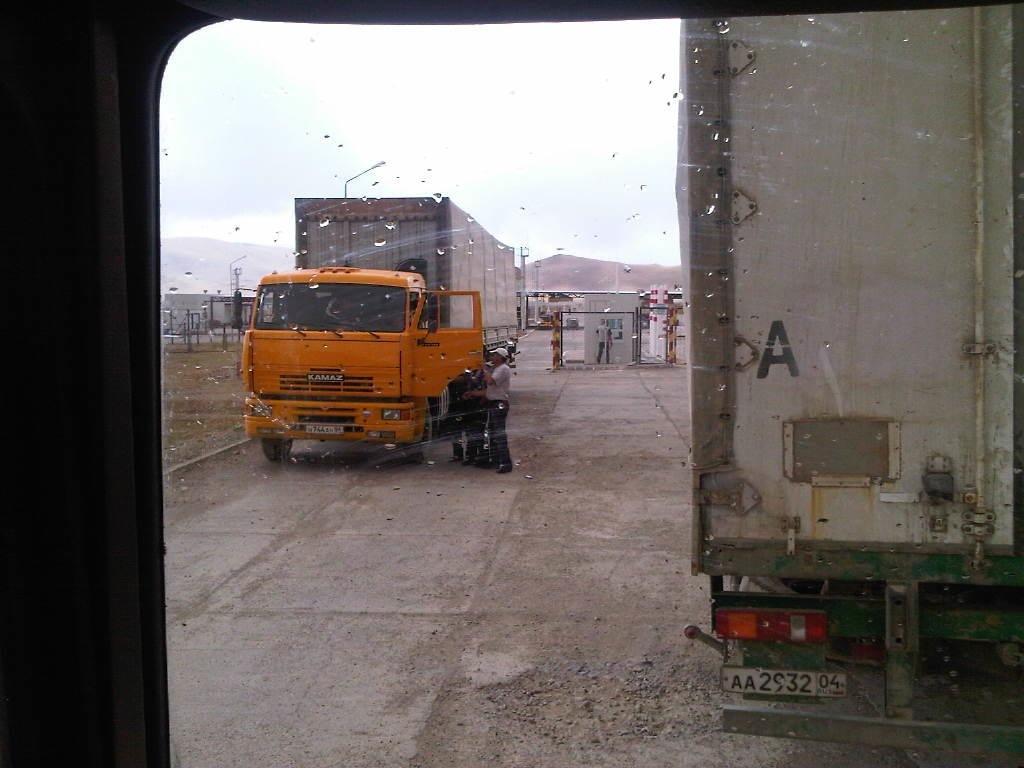In one or two sentences, can you explain what this image depicts? In the foreground of this picture we can see the droplets of water on the glass. In the center we can see the vehicles seems to be parked on the ground and we can see the group of people standing on the ground. In the background we can see the sky, hills, grass, some metal objects and some other objects. 